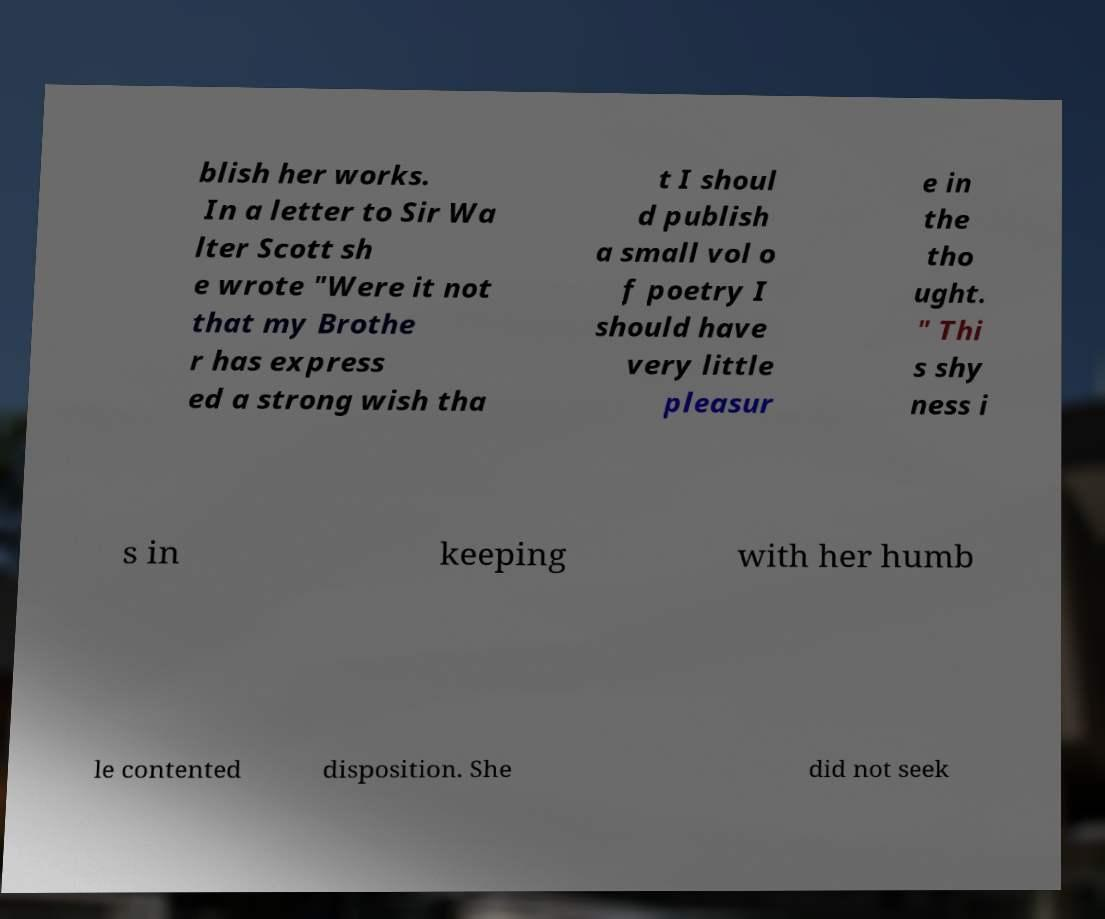I need the written content from this picture converted into text. Can you do that? blish her works. In a letter to Sir Wa lter Scott sh e wrote "Were it not that my Brothe r has express ed a strong wish tha t I shoul d publish a small vol o f poetry I should have very little pleasur e in the tho ught. " Thi s shy ness i s in keeping with her humb le contented disposition. She did not seek 